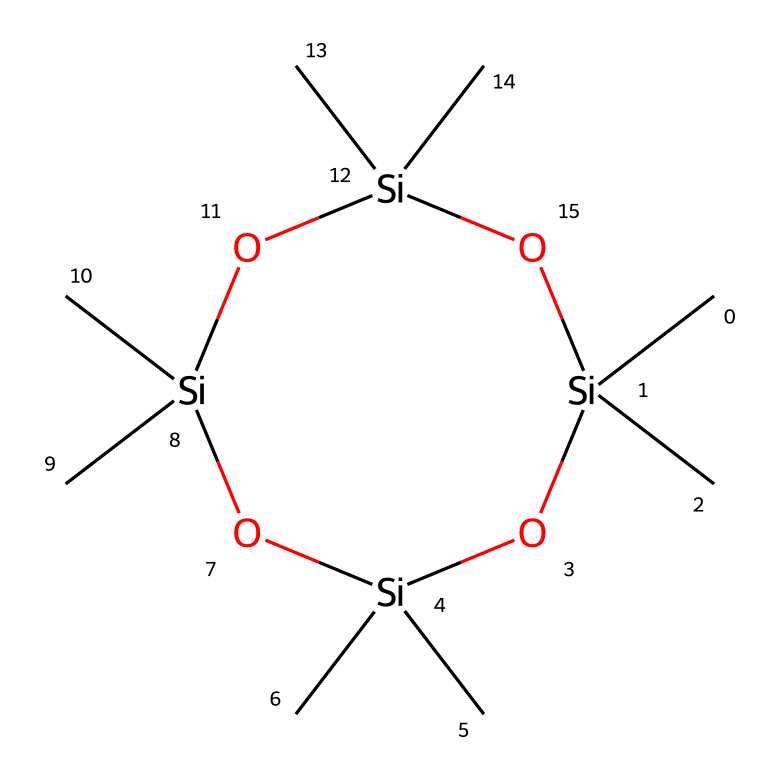What is the name of this chemical? The SMILES representation corresponds to octamethylcyclotetrasiloxane, which is identified by its cyclic structure containing silicon and oxygen atoms.
Answer: octamethylcyclotetrasiloxane How many silicon atoms are present in the structure? The cyclic structure depicted includes four silicon atoms, as indicated by the repeated [Si] in the SMILES notation.
Answer: four What type of bonds connect the silicon atoms? The silicon atoms are connected by Si-O bonds (silicon-oxygen bonds), which are characteristic of siloxane compounds indicated by the 'O' in the SMILES.
Answer: Si-O How many methyl groups are attached to each silicon atom? Each silicon atom is bonded to three methyl groups, as seen in the notation C[Si](C)(C) in the SMILES structure.
Answer: three What kind of molecular structure does octamethylcyclotetrasiloxane have? The molecular structure is cyclic as indicated by the numbering and the connected siloxane rings in the SMILES code, indicating a ring formation with repeating units.
Answer: cyclic What physical property might octamethylcyclotetrasiloxane exhibit due to its composition? Given its structure with multiple siloxane (Si-O) linkages and methyl groups, it likely exhibits flexibility and low viscosity, common to silicone compounds.
Answer: flexibility 